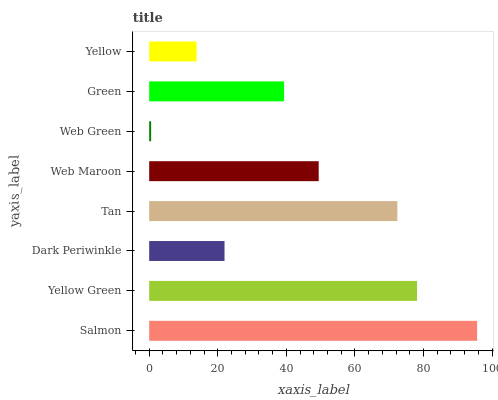Is Web Green the minimum?
Answer yes or no. Yes. Is Salmon the maximum?
Answer yes or no. Yes. Is Yellow Green the minimum?
Answer yes or no. No. Is Yellow Green the maximum?
Answer yes or no. No. Is Salmon greater than Yellow Green?
Answer yes or no. Yes. Is Yellow Green less than Salmon?
Answer yes or no. Yes. Is Yellow Green greater than Salmon?
Answer yes or no. No. Is Salmon less than Yellow Green?
Answer yes or no. No. Is Web Maroon the high median?
Answer yes or no. Yes. Is Green the low median?
Answer yes or no. Yes. Is Green the high median?
Answer yes or no. No. Is Yellow Green the low median?
Answer yes or no. No. 